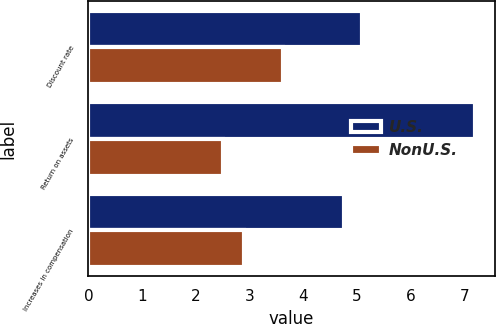Convert chart to OTSL. <chart><loc_0><loc_0><loc_500><loc_500><stacked_bar_chart><ecel><fcel>Discount rate<fcel>Return on assets<fcel>Increases in compensation<nl><fcel>U.S.<fcel>5.1<fcel>7.2<fcel>4.75<nl><fcel>NonU.S.<fcel>3.63<fcel>2.5<fcel>2.9<nl></chart> 